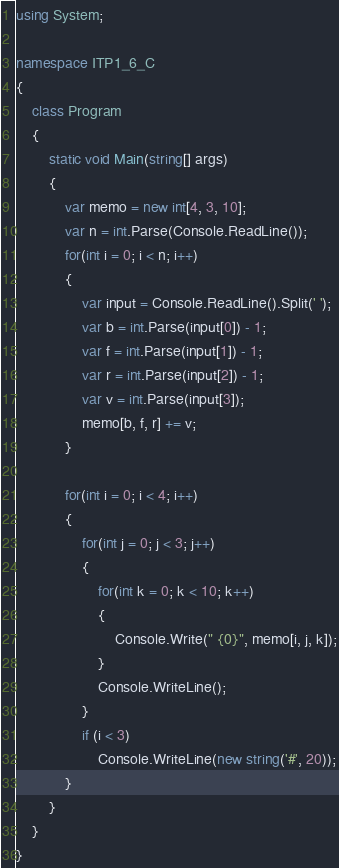Convert code to text. <code><loc_0><loc_0><loc_500><loc_500><_C#_>using System;

namespace ITP1_6_C
{
    class Program
    {
        static void Main(string[] args)
        {
            var memo = new int[4, 3, 10];
            var n = int.Parse(Console.ReadLine());
            for(int i = 0; i < n; i++)
            {
                var input = Console.ReadLine().Split(' ');
                var b = int.Parse(input[0]) - 1;
                var f = int.Parse(input[1]) - 1;
                var r = int.Parse(input[2]) - 1;
                var v = int.Parse(input[3]);
                memo[b, f, r] += v;
            }

            for(int i = 0; i < 4; i++)
            {
                for(int j = 0; j < 3; j++)
                {
                    for(int k = 0; k < 10; k++)
                    {
                        Console.Write(" {0}", memo[i, j, k]);
                    }
                    Console.WriteLine();
                }
                if (i < 3)
                    Console.WriteLine(new string('#', 20));
            }
        }
    }
}</code> 